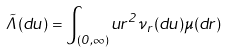Convert formula to latex. <formula><loc_0><loc_0><loc_500><loc_500>\tilde { \Lambda } ( d u ) = \int _ { ( 0 , \infty ) } u r ^ { 2 } \nu _ { r } ( d u ) \mu ( d r )</formula> 